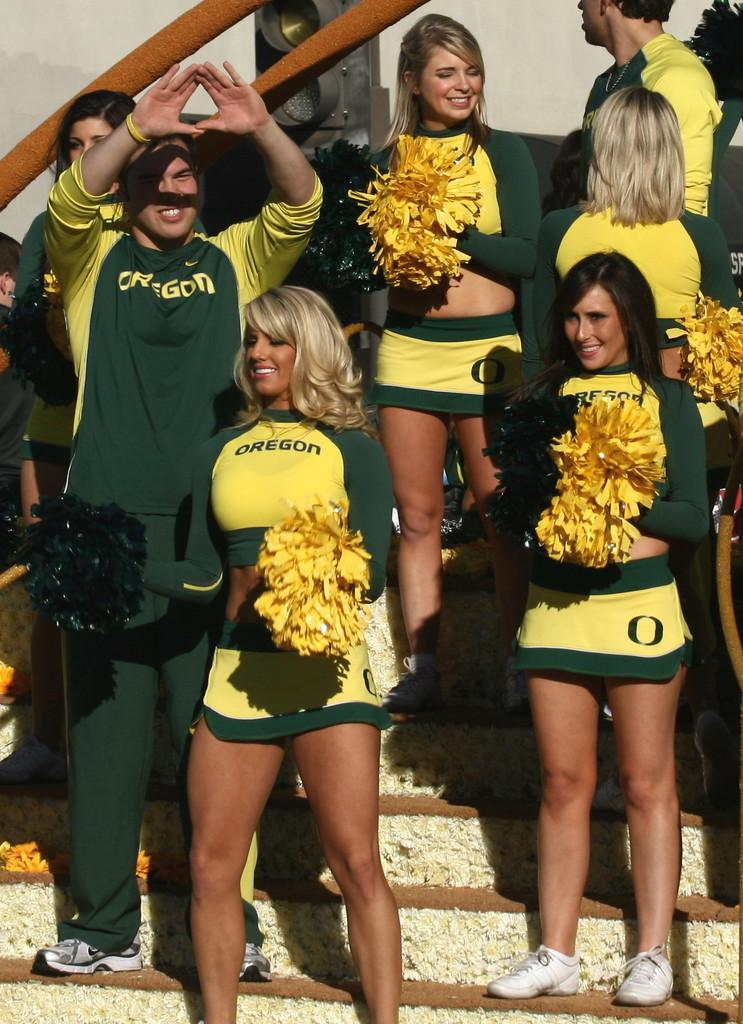<image>
Create a compact narrative representing the image presented. The cheerleaders from Oregon State University are watching the game and socializing. 